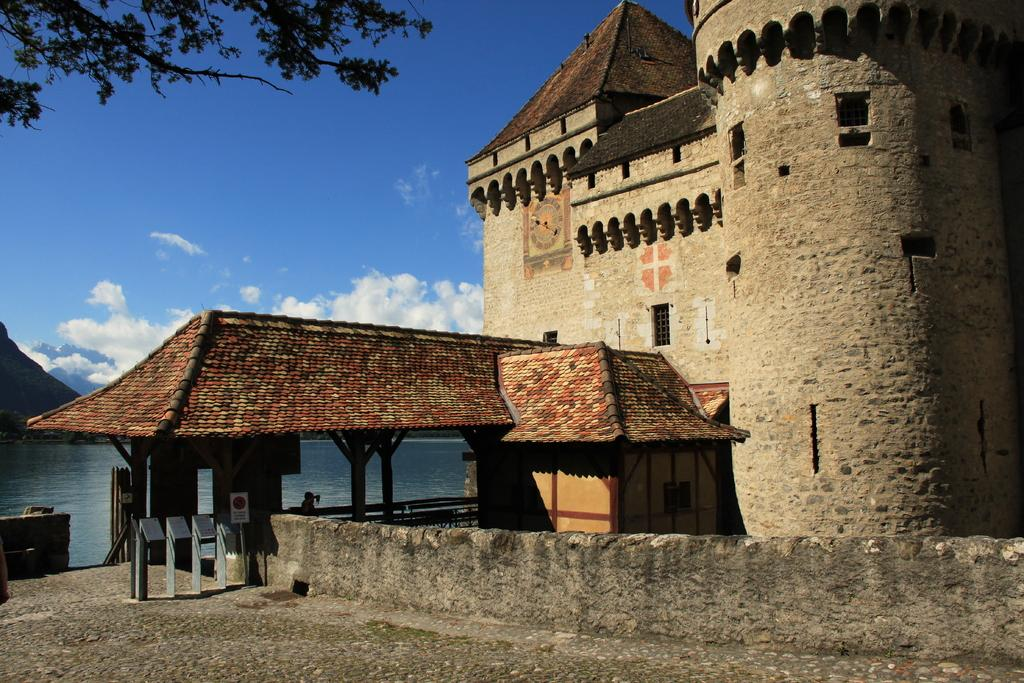What structure with a red color roof can be seen on the left side of the image? There is a shed with a red color roof on the left side of the image. What other object is located on the left side of the image? There is a tree on the left side of the image. What type of building is present in the image? There is a stone building in the image. What can be seen in the sky in the image? There are clouds in the sky in the image. Can you see a person riding a railway in the image? There is no railway or person riding a railway present in the image. What type of roof is on the stone building in the image? The provided facts do not mention the roof of the stone building, so we cannot answer this question definitively. 